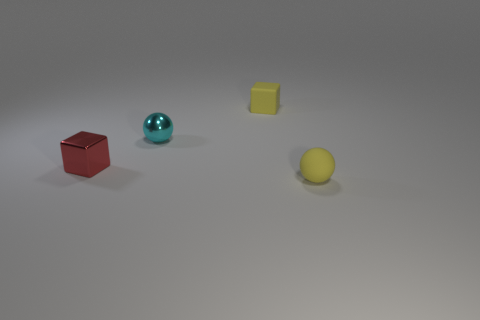Is the color of the rubber cube the same as the matte sphere?
Your answer should be very brief. Yes. There is another ball that is the same size as the cyan metal sphere; what is its material?
Your response must be concise. Rubber. How many rubber things are small yellow blocks or blue balls?
Offer a terse response. 1. There is a object that is in front of the cyan sphere and right of the small cyan ball; what color is it?
Your answer should be very brief. Yellow. There is a small yellow ball; how many yellow rubber objects are behind it?
Provide a succinct answer. 1. What is the tiny yellow block made of?
Provide a succinct answer. Rubber. What color is the rubber object behind the tiny rubber object that is in front of the small matte object that is behind the tiny cyan metal ball?
Make the answer very short. Yellow. How many cyan metal balls have the same size as the red metallic block?
Keep it short and to the point. 1. What color is the block that is behind the tiny red cube?
Give a very brief answer. Yellow. What number of other objects are there of the same size as the cyan sphere?
Your response must be concise. 3. 